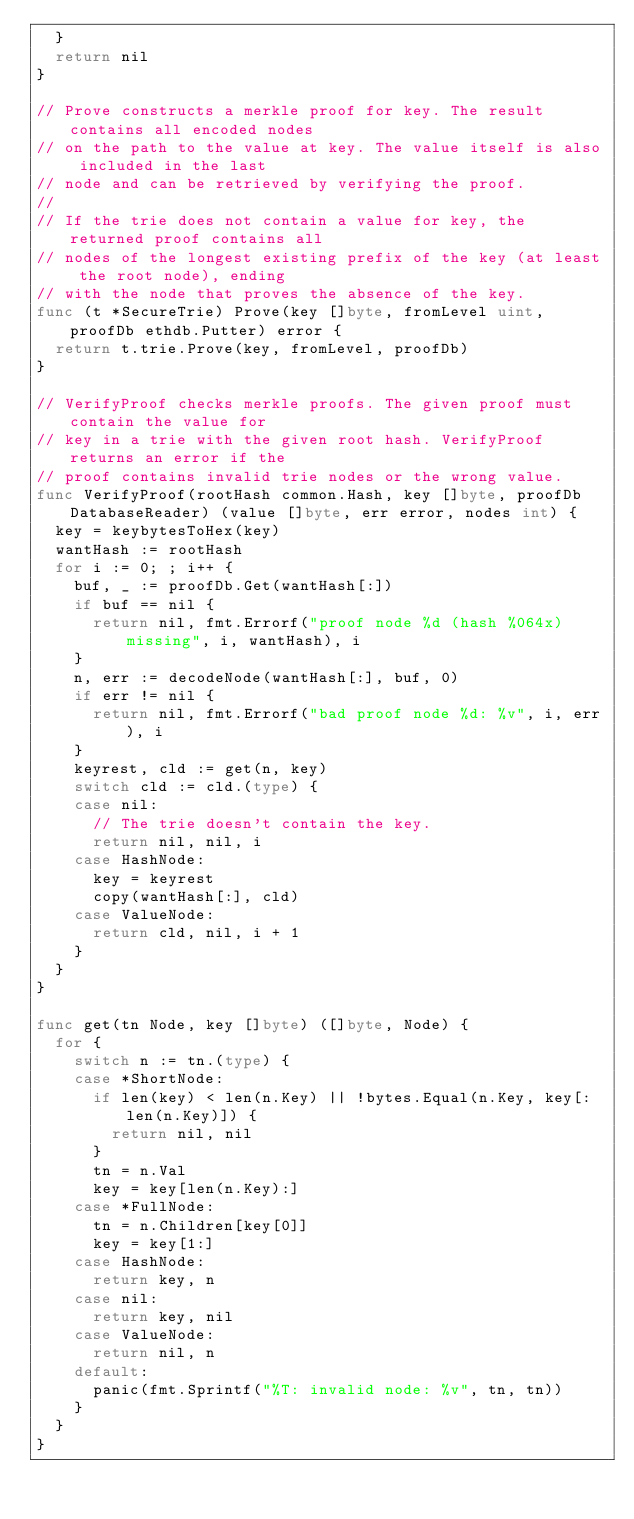<code> <loc_0><loc_0><loc_500><loc_500><_Go_>	}
	return nil
}

// Prove constructs a merkle proof for key. The result contains all encoded nodes
// on the path to the value at key. The value itself is also included in the last
// node and can be retrieved by verifying the proof.
//
// If the trie does not contain a value for key, the returned proof contains all
// nodes of the longest existing prefix of the key (at least the root node), ending
// with the node that proves the absence of the key.
func (t *SecureTrie) Prove(key []byte, fromLevel uint, proofDb ethdb.Putter) error {
	return t.trie.Prove(key, fromLevel, proofDb)
}

// VerifyProof checks merkle proofs. The given proof must contain the value for
// key in a trie with the given root hash. VerifyProof returns an error if the
// proof contains invalid trie nodes or the wrong value.
func VerifyProof(rootHash common.Hash, key []byte, proofDb DatabaseReader) (value []byte, err error, nodes int) {
	key = keybytesToHex(key)
	wantHash := rootHash
	for i := 0; ; i++ {
		buf, _ := proofDb.Get(wantHash[:])
		if buf == nil {
			return nil, fmt.Errorf("proof node %d (hash %064x) missing", i, wantHash), i
		}
		n, err := decodeNode(wantHash[:], buf, 0)
		if err != nil {
			return nil, fmt.Errorf("bad proof node %d: %v", i, err), i
		}
		keyrest, cld := get(n, key)
		switch cld := cld.(type) {
		case nil:
			// The trie doesn't contain the key.
			return nil, nil, i
		case HashNode:
			key = keyrest
			copy(wantHash[:], cld)
		case ValueNode:
			return cld, nil, i + 1
		}
	}
}

func get(tn Node, key []byte) ([]byte, Node) {
	for {
		switch n := tn.(type) {
		case *ShortNode:
			if len(key) < len(n.Key) || !bytes.Equal(n.Key, key[:len(n.Key)]) {
				return nil, nil
			}
			tn = n.Val
			key = key[len(n.Key):]
		case *FullNode:
			tn = n.Children[key[0]]
			key = key[1:]
		case HashNode:
			return key, n
		case nil:
			return key, nil
		case ValueNode:
			return nil, n
		default:
			panic(fmt.Sprintf("%T: invalid node: %v", tn, tn))
		}
	}
}
</code> 